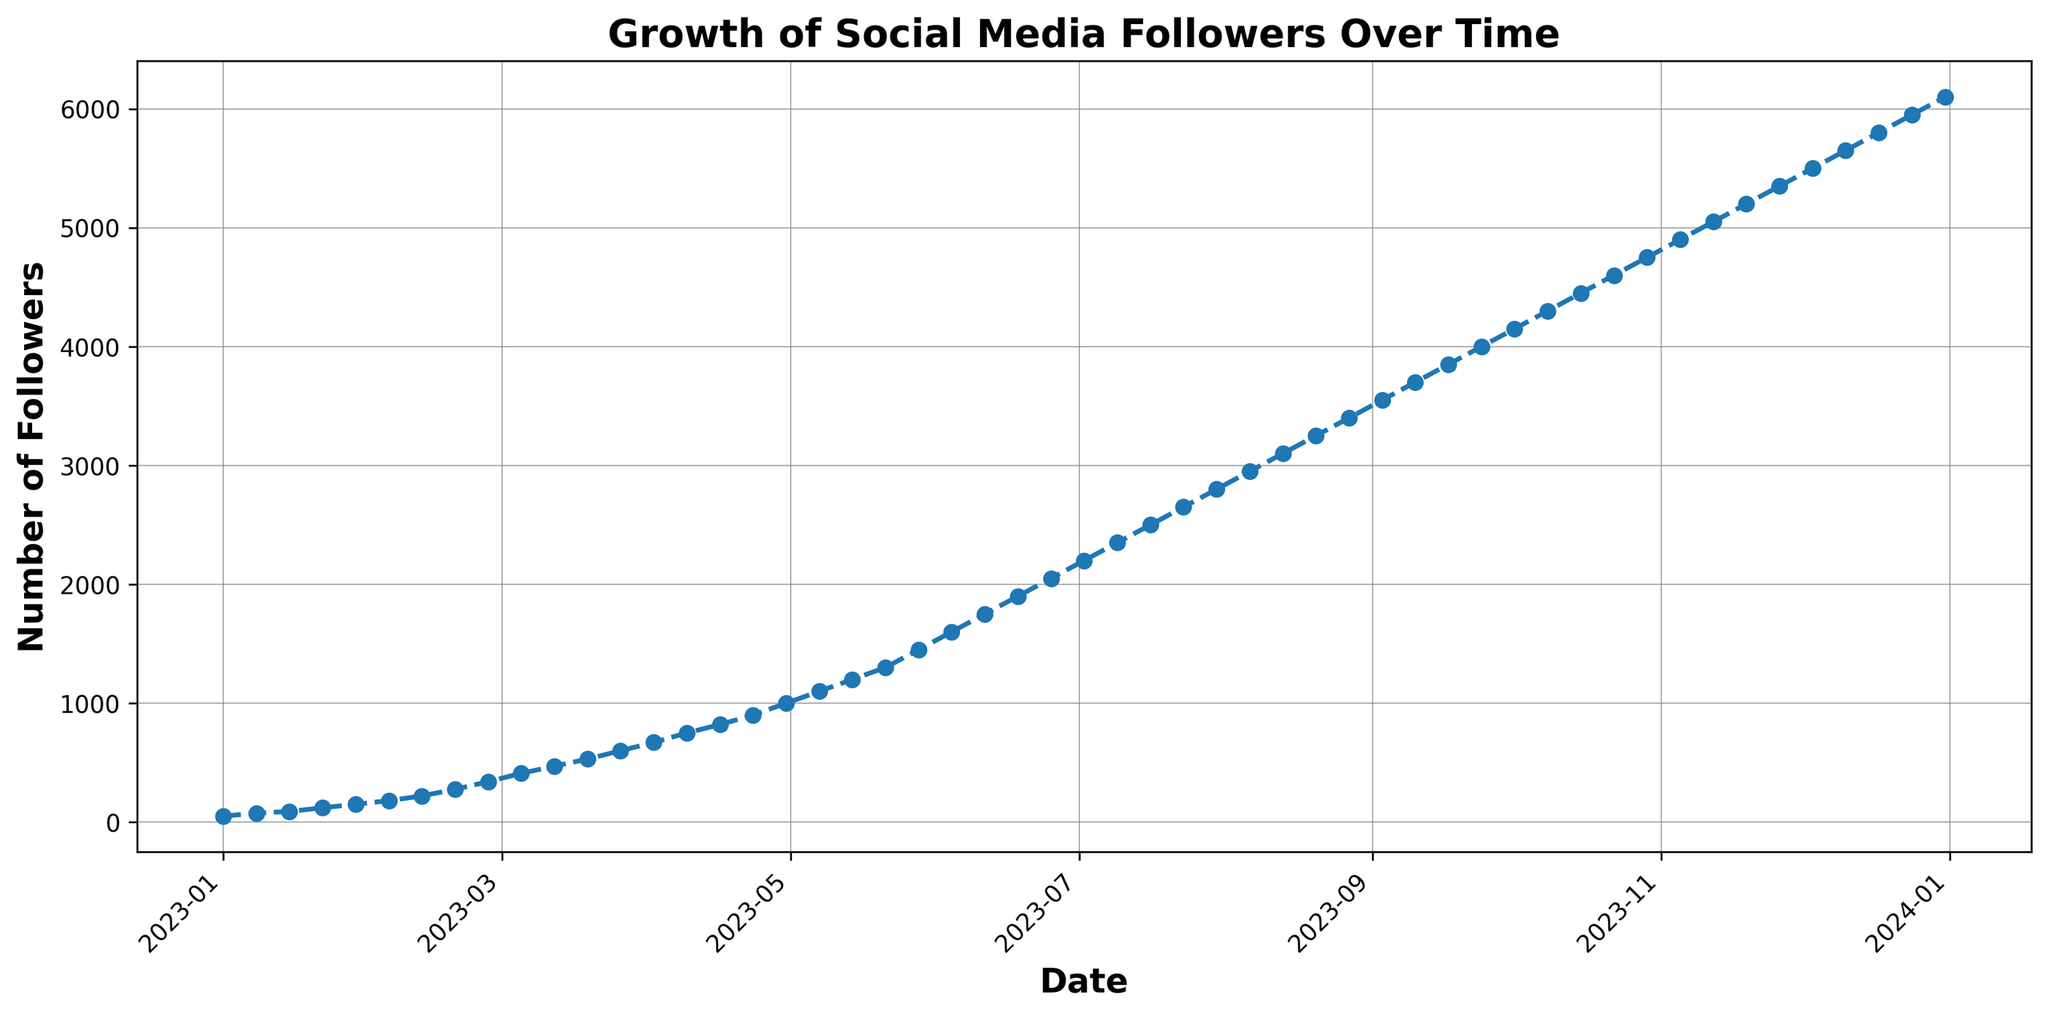What is the approximate number of followers by the end of March 2023? To find the approximate number of followers by the end of March 2023, look at the data point corresponding to 2023-03-31. The trend line intersects this date at around 600 followers.
Answer: 600 By how many followers did your fan base grow between February 5, 2023, and March 5, 2023? Check the figure for the values on February 5, 2023 (180 followers), and March 5, 2023 (410 followers). Calculate the difference: 410 - 180 = 230 followers.
Answer: 230 Between which two consecutive weeks did you see the highest increase in followers? Observe the steepest slope between any two consecutive points. The steepest increase is between February 19, 2023, and February 26, 2023, where the number of followers rose from 275 to 340, an increase of 65 followers.
Answer: February 19, 2023, and February 26, 2023 What is the average number of followers for the first month shown in the graph? For January 2023, take the number of followers for each week: 50, 75, 90, and 120. Calculate the average (50 + 75 + 90 + 120) / 4 = 335 / 4 = 83.75 followers.
Answer: 83.75 By how much did the number of followers increase in the first quarter compared to the second quarter of 2023? First quarter: January to March (50 to 600 followers, increase of 550). Second quarter: April to June (670 to 2050 followers, increase of 1380). The difference between the two increases is 1380 - 550 = 830 followers.
Answer: 830 How does the growth rate compare between the first six months and the second six months depicted in the chart? First six months: January to June (50 to 2050 followers, an increase of 2000). Second six months: July to December (2200 to 6100 followers, an increase of 3900). The second six months show a significantly higher growth rate.
Answer: Higher in the second six months What is the trend shown in the chart? The chart shows a consistently increasing trend of social media followers over time. The growth rate accelerates noticeably after the initial months.
Answer: Increased, accelerating On which date did the followers reach 2000? Following the trend line, the number of followers reached 2000 around June 25, 2023.
Answer: June 25, 2023 By how many followers did your fan base grow in the entire year of 2023? The number of followers at the beginning of the year is 50, and at the end is 6100. The total growth is 6100 - 50 = 6050 followers.
Answer: 6050 